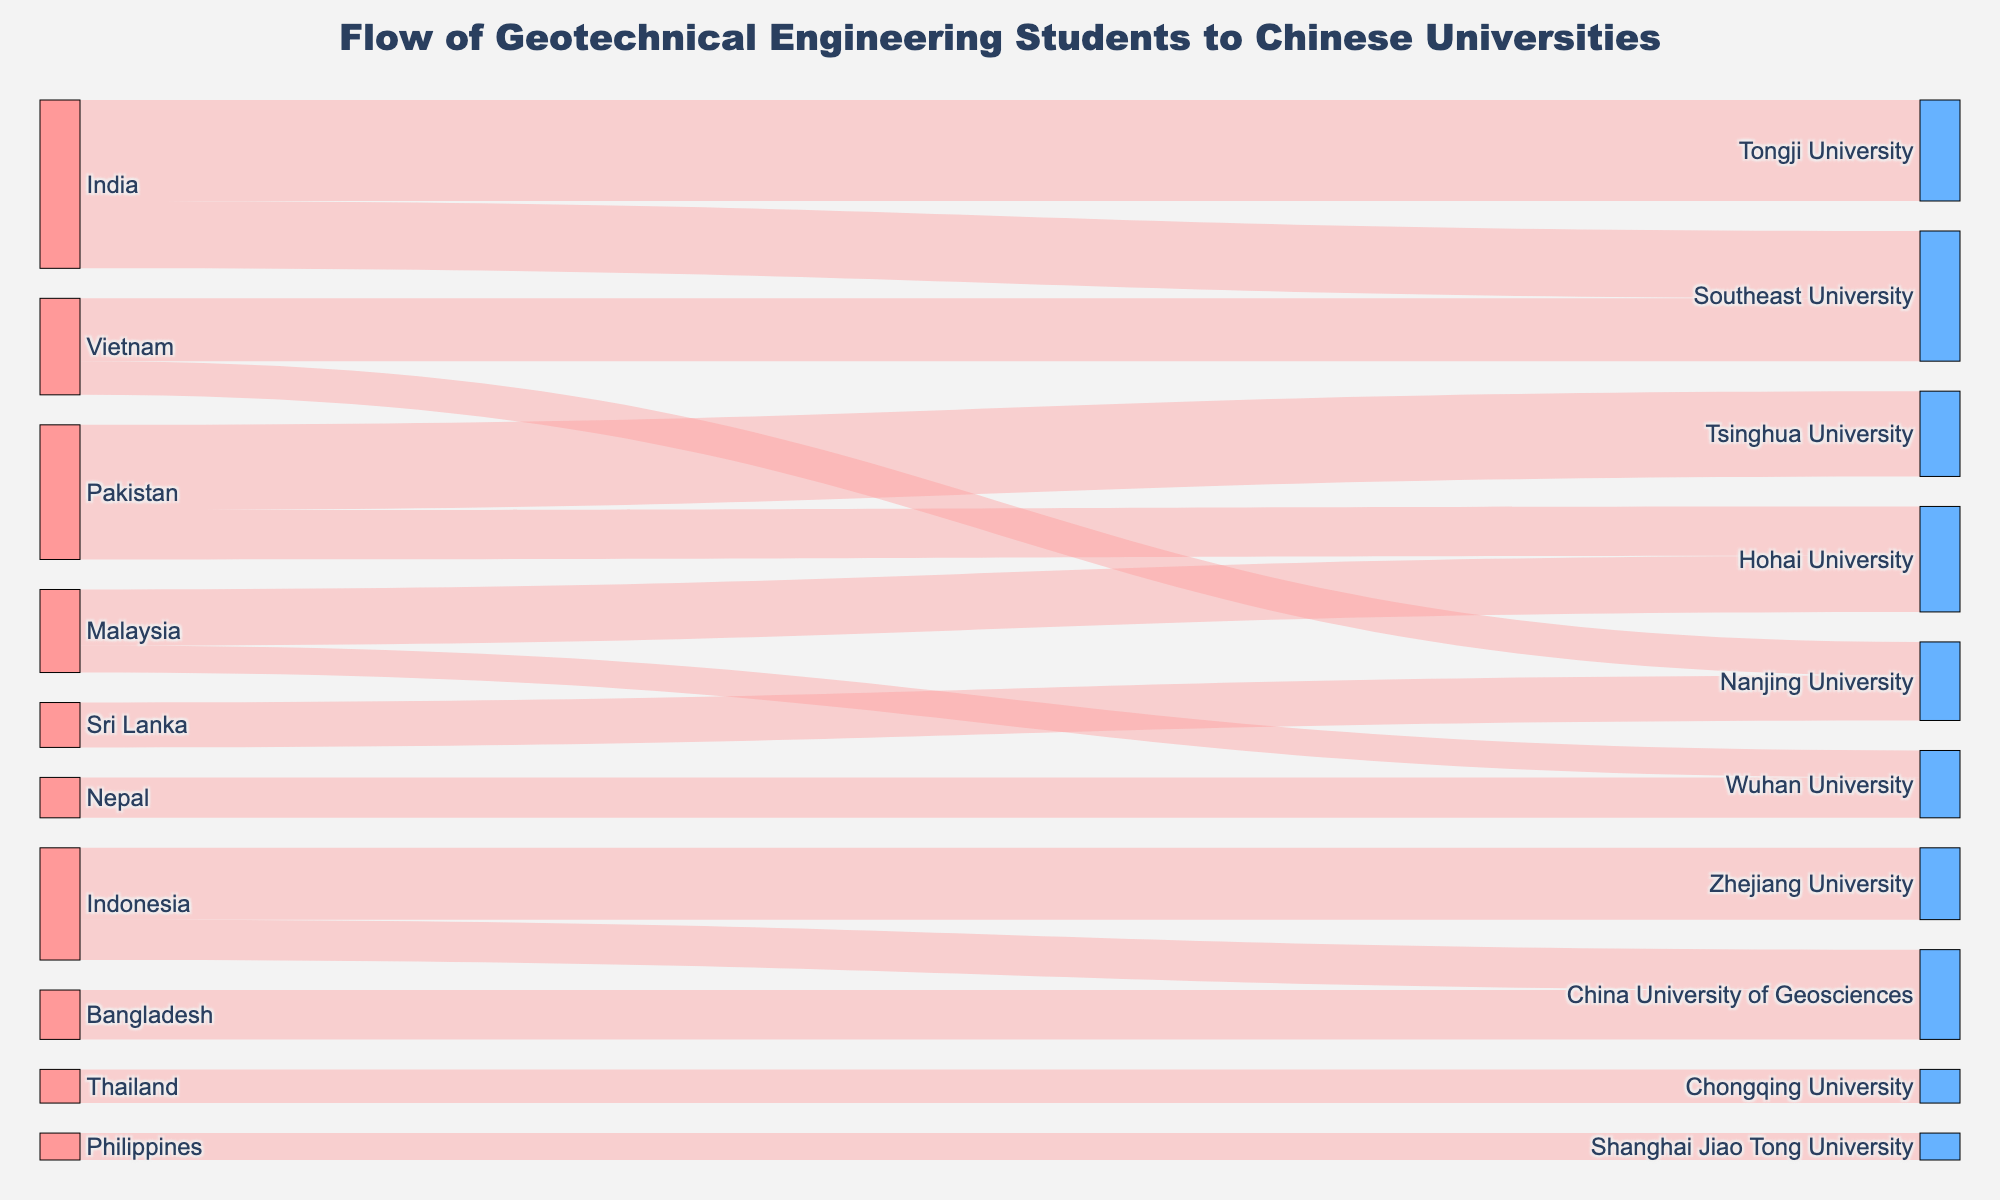What is the title of the figure? The title is prominently displayed at the top of the figure.
Answer: Flow of Geotechnical Engineering Students to Chinese Universities Which university in China receives the most geotechnical engineering students from India? Look for the flow from India to different universities and find the one with the highest value.
Answer: Tongji University How many students from Pakistan go to Tsinghua University? Follow the flow from Pakistan to Tsinghua University and read the value there.
Answer: 38 How many Malaysian students study at Hohai University? Identify the flow from Malaysia to Hohai University and check the value.
Answer: 25 Which university in China has the fewest students from Indonesia? Compare the values of the flows from Indonesia to different universities and identify the smallest one.
Answer: China University of Geosciences What is the total number of students from Vietnam studying in Chinese universities? Sum up the values of all the flows originating from Vietnam.
Answer: 28 + 15 = 43 How does the number of students from Nepal studying in Wuhan University compare to those in Nanjing University? Find the values of the flows from Nepal to Wuhan University and Nanjing University, then compare them.
Answer: Wuhan University (18) is greater than Nanjing University (15) Which country sends students to the most universities in China? Count the number of distinct universities each country is sending students to.
Answer: India What is the combined total of students from Bangladesh and Sri Lanka studying in China University of Geosciences? Add the value from Bangladesh to China University of Geosciences and any other flow from Sri Lanka to the same university.
Answer: 22 (Bangladesh) + 0 (Sri Lanka) = 22 How many more students does Tongji University receive compared to Hohai University from all countries? Sum the values of all incoming flows to each university, then find the difference. Tongji University receives 45 from India; Hohai University receives 25 from Malaysia and 22 from Pakistan.
Answer: 45 - (25 + 22) = 45 - 47 = -2 (Tongji University receives 2 fewer students) 